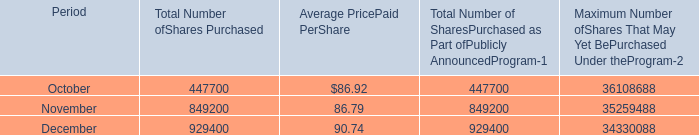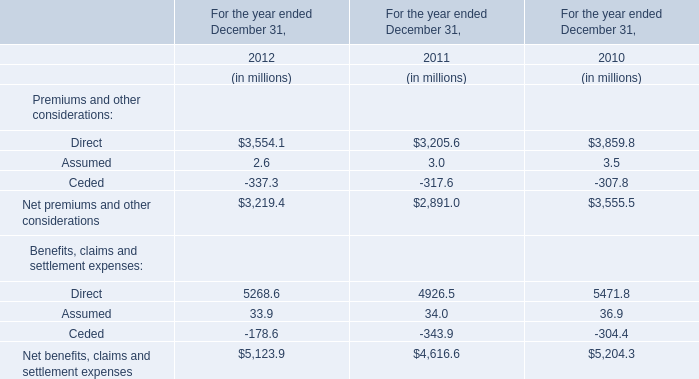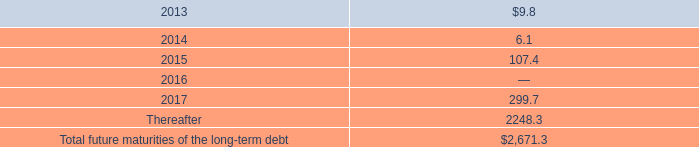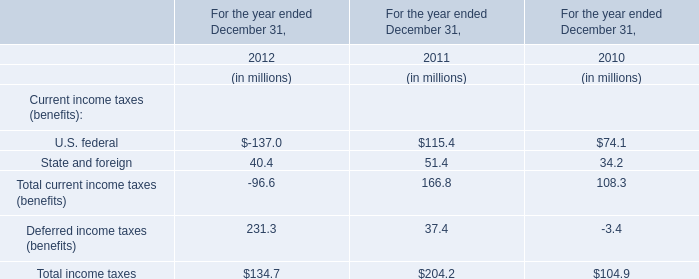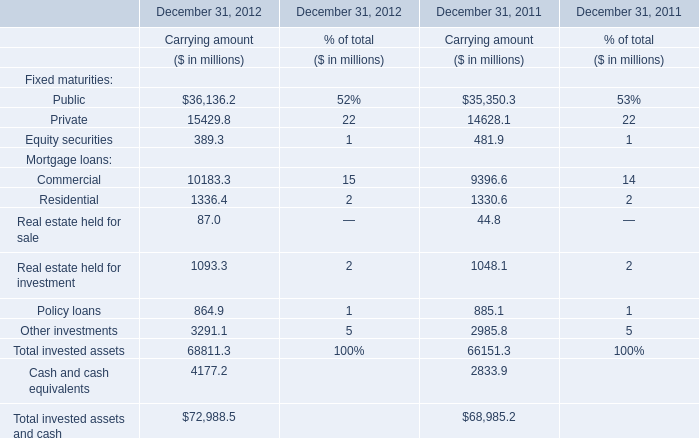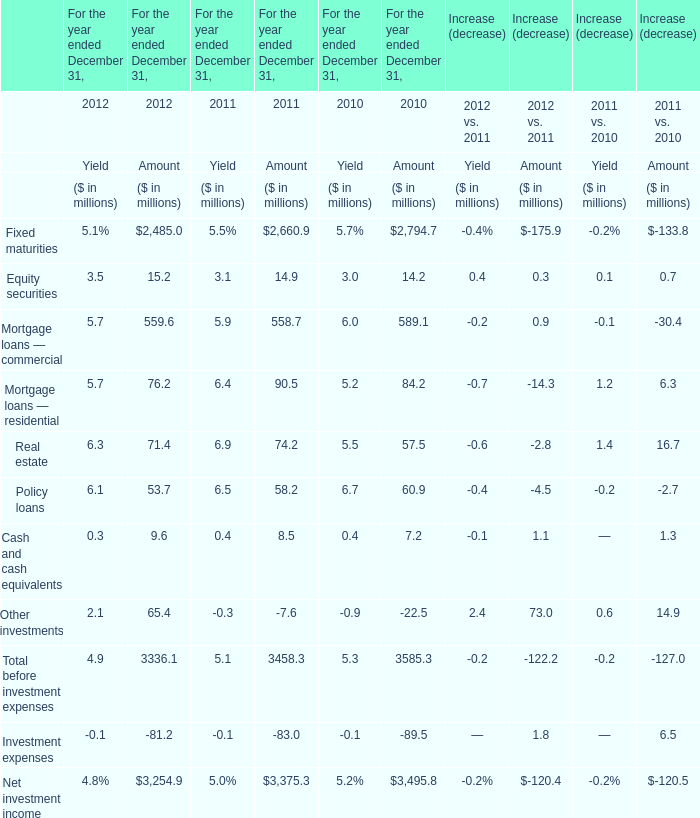What is the sum of the Equity securities of Fixed maturities for Carrying amount in the years where Public of Fixed maturities for Carrying amount is positive? (in million) 
Computations: (389.3 + 481.9)
Answer: 871.2. 